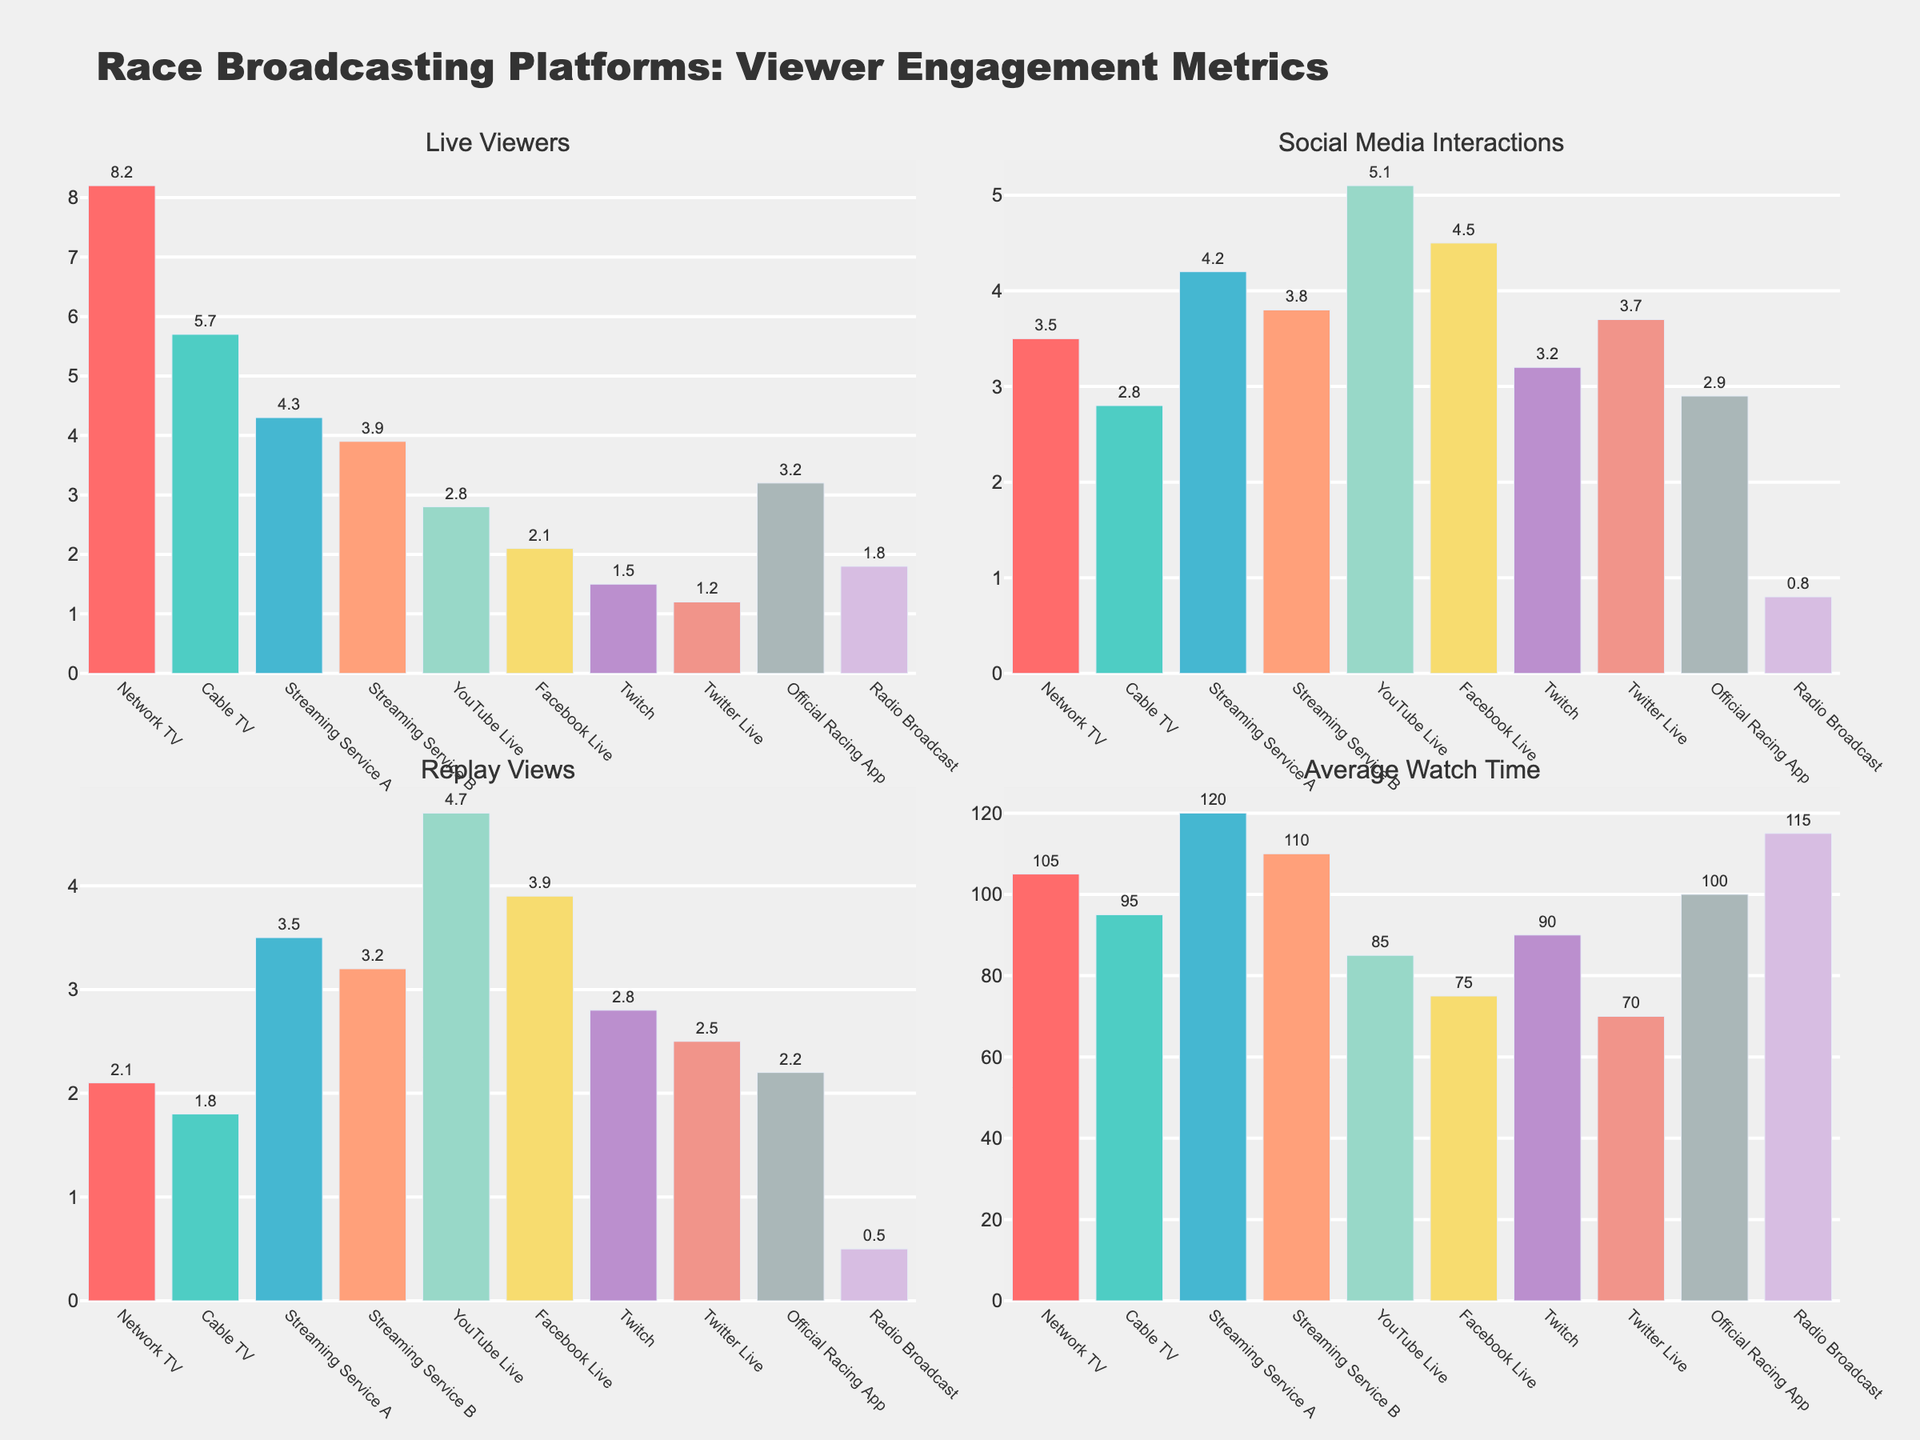Which platform has the highest number of live viewers? By looking at the "Live Viewers" subplot, identify the bar with the greatest height. It's the "Network TV" bar.
Answer: Network TV Which platform has the lowest number of social media interactions? In the "Social Media Interactions" subplot, find the bar with the smallest height. It corresponds to the "Radio Broadcast" platform.
Answer: Radio Broadcast Compare the average watch time of Streaming Service A to Network TV. Which is higher? Observe the "Average Watch Time" subplot; compare the heights of the bars for "Streaming Service A" and "Network TV". Streaming Service A has a higher bar.
Answer: Streaming Service A Which platform has more replay views, YouTube Live or Facebook Live? Refer to the "Replay Views" subplot and compare the heights of the bars for "YouTube Live" and "Facebook Live". The YouTube Live bar is taller.
Answer: YouTube Live What is the sum of live viewers for Network TV and Cable TV? Add the live viewers for Network TV (8.2 million) and Cable TV (5.7 million). 8.2 + 5.7 = 13.9 million.
Answer: 13.9 million What is the difference between the average watch time of Twitch and Twitter Live? Subtract the average watch time of Twitter Live (70 minutes) from Twitch (90 minutes). 90 - 70 = 20 minutes.
Answer: 20 minutes Which platform has a higher number of social media interactions, Twitter Live or the Official Racing App? Refer to the "Social Media Interactions" subplot, compare the heights of the bars for "Twitter Live" and "Official Racing App". The Twitter Live bar is taller.
Answer: Twitter Live Which platform has the most engagement in replay views besides YouTube Live? In the "Replay Views" subplot, disregard YouTube Live and identify the second tallest bar. It corresponds to "Facebook Live".
Answer: Facebook Live What is the combined number of social media interactions for Facebook Live and Twitch? Add the social media interactions for Facebook Live (4.5 million) and Twitch (3.2 million). 4.5 + 3.2 = 7.7 million.
Answer: 7.7 million How many platforms have an average watch time above 100 minutes? Check the "Average Watch Time" subplot and count the number of bars exceeding the 100-minute mark. These platforms are Network TV, Streaming Service A, Streaming Service B, and Radio Broadcast, giving a count of 4.
Answer: 4 